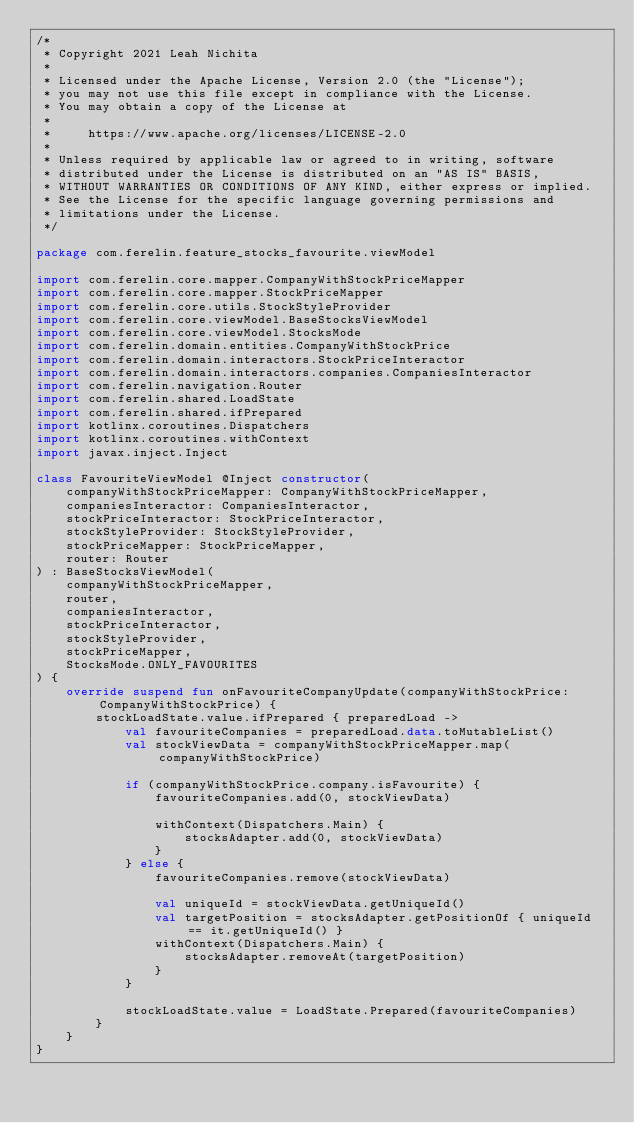Convert code to text. <code><loc_0><loc_0><loc_500><loc_500><_Kotlin_>/*
 * Copyright 2021 Leah Nichita
 *
 * Licensed under the Apache License, Version 2.0 (the "License");
 * you may not use this file except in compliance with the License.
 * You may obtain a copy of the License at
 *
 *     https://www.apache.org/licenses/LICENSE-2.0
 *
 * Unless required by applicable law or agreed to in writing, software
 * distributed under the License is distributed on an "AS IS" BASIS,
 * WITHOUT WARRANTIES OR CONDITIONS OF ANY KIND, either express or implied.
 * See the License for the specific language governing permissions and
 * limitations under the License.
 */

package com.ferelin.feature_stocks_favourite.viewModel

import com.ferelin.core.mapper.CompanyWithStockPriceMapper
import com.ferelin.core.mapper.StockPriceMapper
import com.ferelin.core.utils.StockStyleProvider
import com.ferelin.core.viewModel.BaseStocksViewModel
import com.ferelin.core.viewModel.StocksMode
import com.ferelin.domain.entities.CompanyWithStockPrice
import com.ferelin.domain.interactors.StockPriceInteractor
import com.ferelin.domain.interactors.companies.CompaniesInteractor
import com.ferelin.navigation.Router
import com.ferelin.shared.LoadState
import com.ferelin.shared.ifPrepared
import kotlinx.coroutines.Dispatchers
import kotlinx.coroutines.withContext
import javax.inject.Inject

class FavouriteViewModel @Inject constructor(
    companyWithStockPriceMapper: CompanyWithStockPriceMapper,
    companiesInteractor: CompaniesInteractor,
    stockPriceInteractor: StockPriceInteractor,
    stockStyleProvider: StockStyleProvider,
    stockPriceMapper: StockPriceMapper,
    router: Router
) : BaseStocksViewModel(
    companyWithStockPriceMapper,
    router,
    companiesInteractor,
    stockPriceInteractor,
    stockStyleProvider,
    stockPriceMapper,
    StocksMode.ONLY_FAVOURITES
) {
    override suspend fun onFavouriteCompanyUpdate(companyWithStockPrice: CompanyWithStockPrice) {
        stockLoadState.value.ifPrepared { preparedLoad ->
            val favouriteCompanies = preparedLoad.data.toMutableList()
            val stockViewData = companyWithStockPriceMapper.map(companyWithStockPrice)

            if (companyWithStockPrice.company.isFavourite) {
                favouriteCompanies.add(0, stockViewData)

                withContext(Dispatchers.Main) {
                    stocksAdapter.add(0, stockViewData)
                }
            } else {
                favouriteCompanies.remove(stockViewData)

                val uniqueId = stockViewData.getUniqueId()
                val targetPosition = stocksAdapter.getPositionOf { uniqueId == it.getUniqueId() }
                withContext(Dispatchers.Main) {
                    stocksAdapter.removeAt(targetPosition)
                }
            }

            stockLoadState.value = LoadState.Prepared(favouriteCompanies)
        }
    }
}</code> 